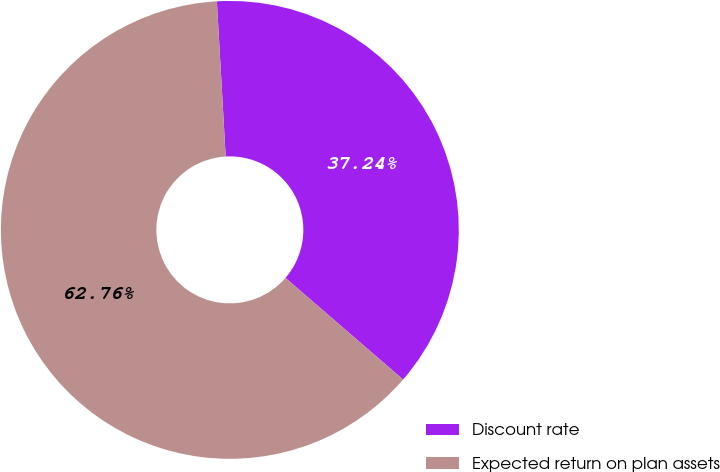Convert chart. <chart><loc_0><loc_0><loc_500><loc_500><pie_chart><fcel>Discount rate<fcel>Expected return on plan assets<nl><fcel>37.24%<fcel>62.76%<nl></chart> 